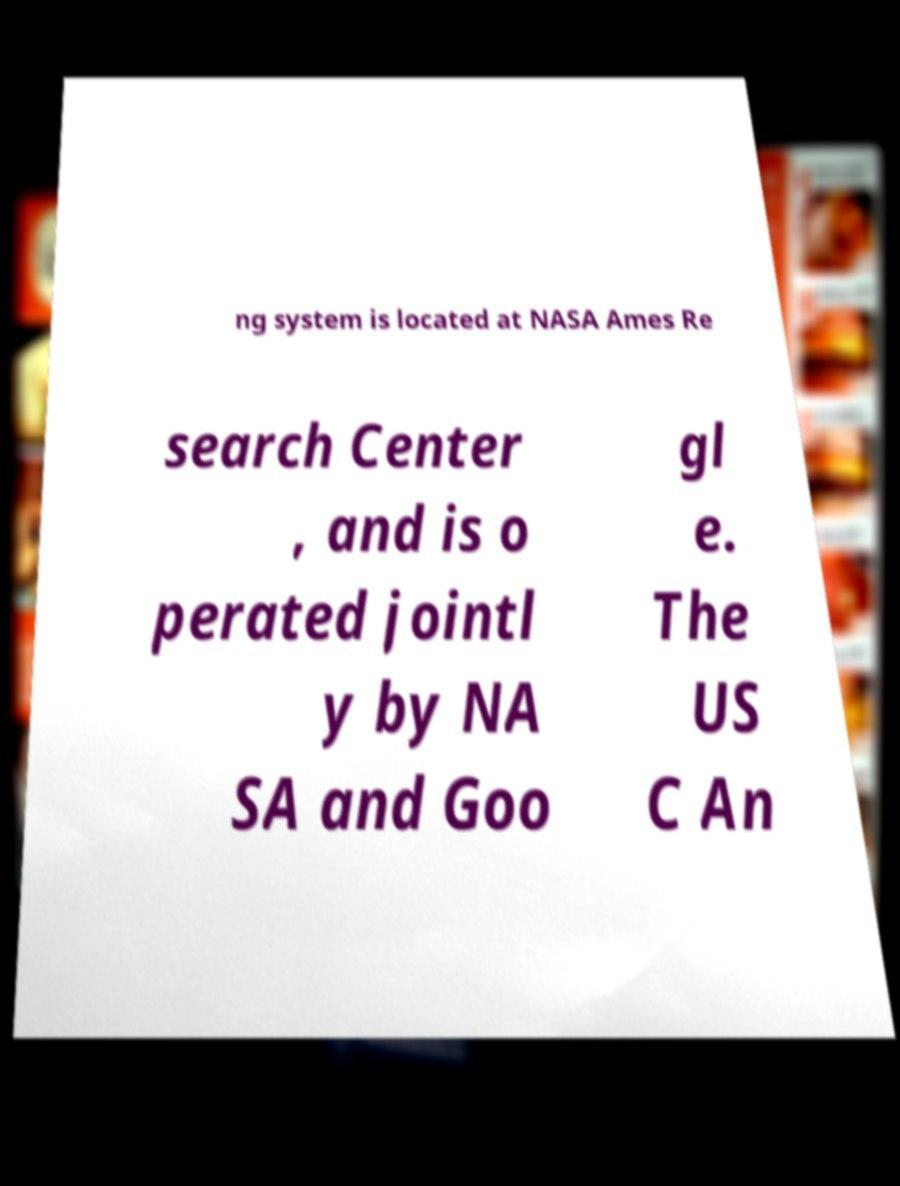Can you accurately transcribe the text from the provided image for me? ng system is located at NASA Ames Re search Center , and is o perated jointl y by NA SA and Goo gl e. The US C An 